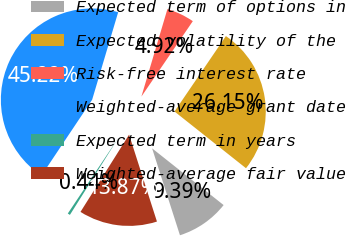Convert chart. <chart><loc_0><loc_0><loc_500><loc_500><pie_chart><fcel>Expected term of options in<fcel>Expected volatility of the<fcel>Risk-free interest rate<fcel>Weighted-average grant date<fcel>Expected term in years<fcel>Weighted-average fair value<nl><fcel>9.39%<fcel>26.15%<fcel>4.92%<fcel>45.22%<fcel>0.44%<fcel>13.87%<nl></chart> 